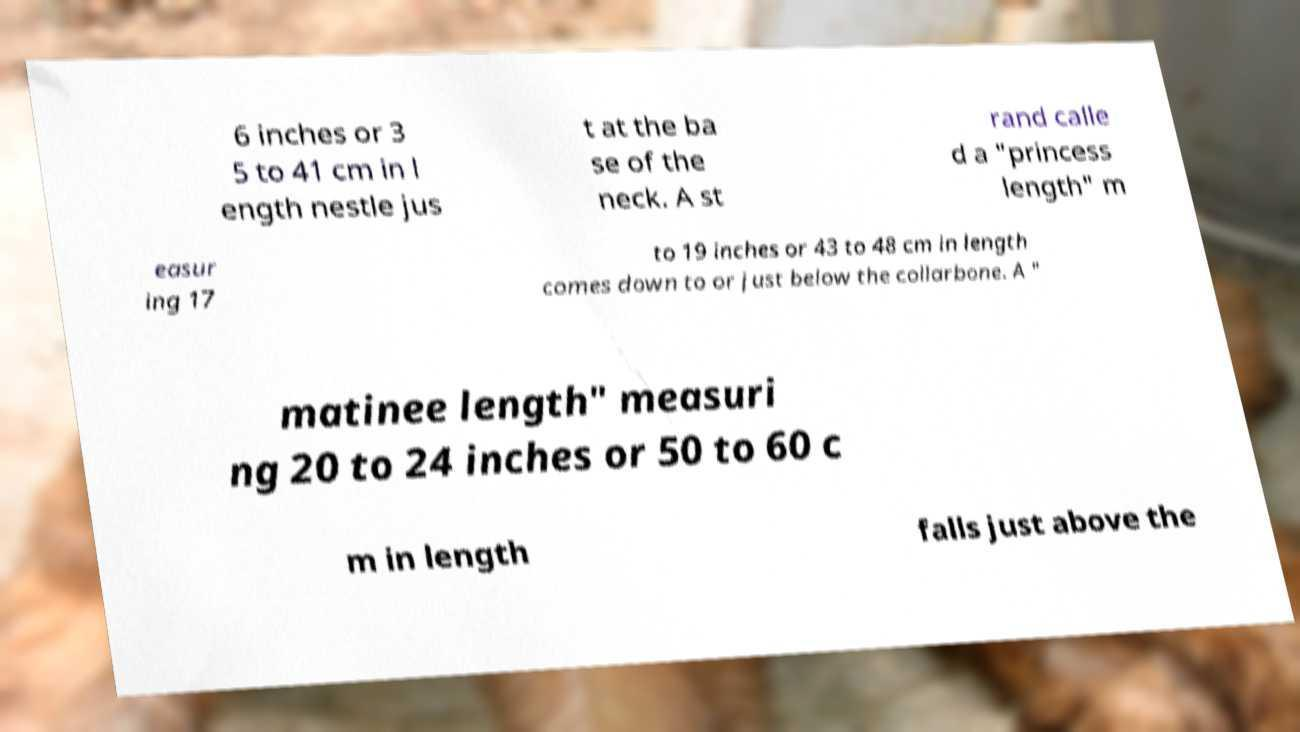For documentation purposes, I need the text within this image transcribed. Could you provide that? 6 inches or 3 5 to 41 cm in l ength nestle jus t at the ba se of the neck. A st rand calle d a "princess length" m easur ing 17 to 19 inches or 43 to 48 cm in length comes down to or just below the collarbone. A " matinee length" measuri ng 20 to 24 inches or 50 to 60 c m in length falls just above the 